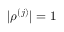<formula> <loc_0><loc_0><loc_500><loc_500>| \rho ^ { ( j ) } | = 1</formula> 